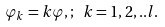<formula> <loc_0><loc_0><loc_500><loc_500>\varphi _ { k } = k \varphi , ; \ k = 1 , 2 , . . l .</formula> 